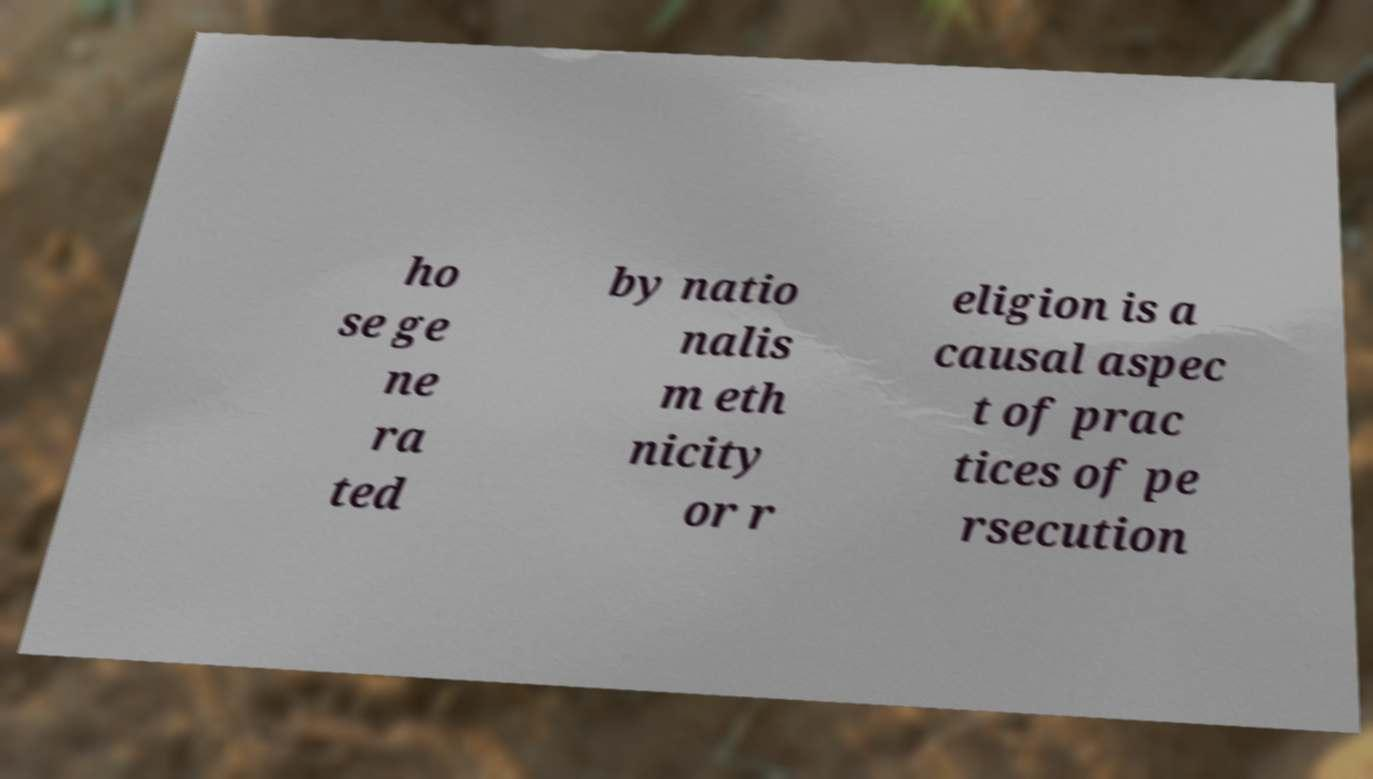Please identify and transcribe the text found in this image. ho se ge ne ra ted by natio nalis m eth nicity or r eligion is a causal aspec t of prac tices of pe rsecution 